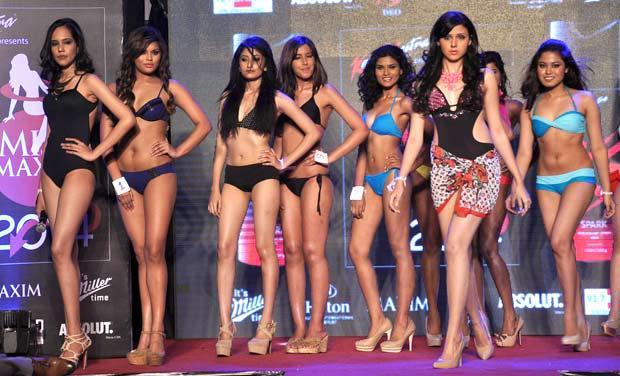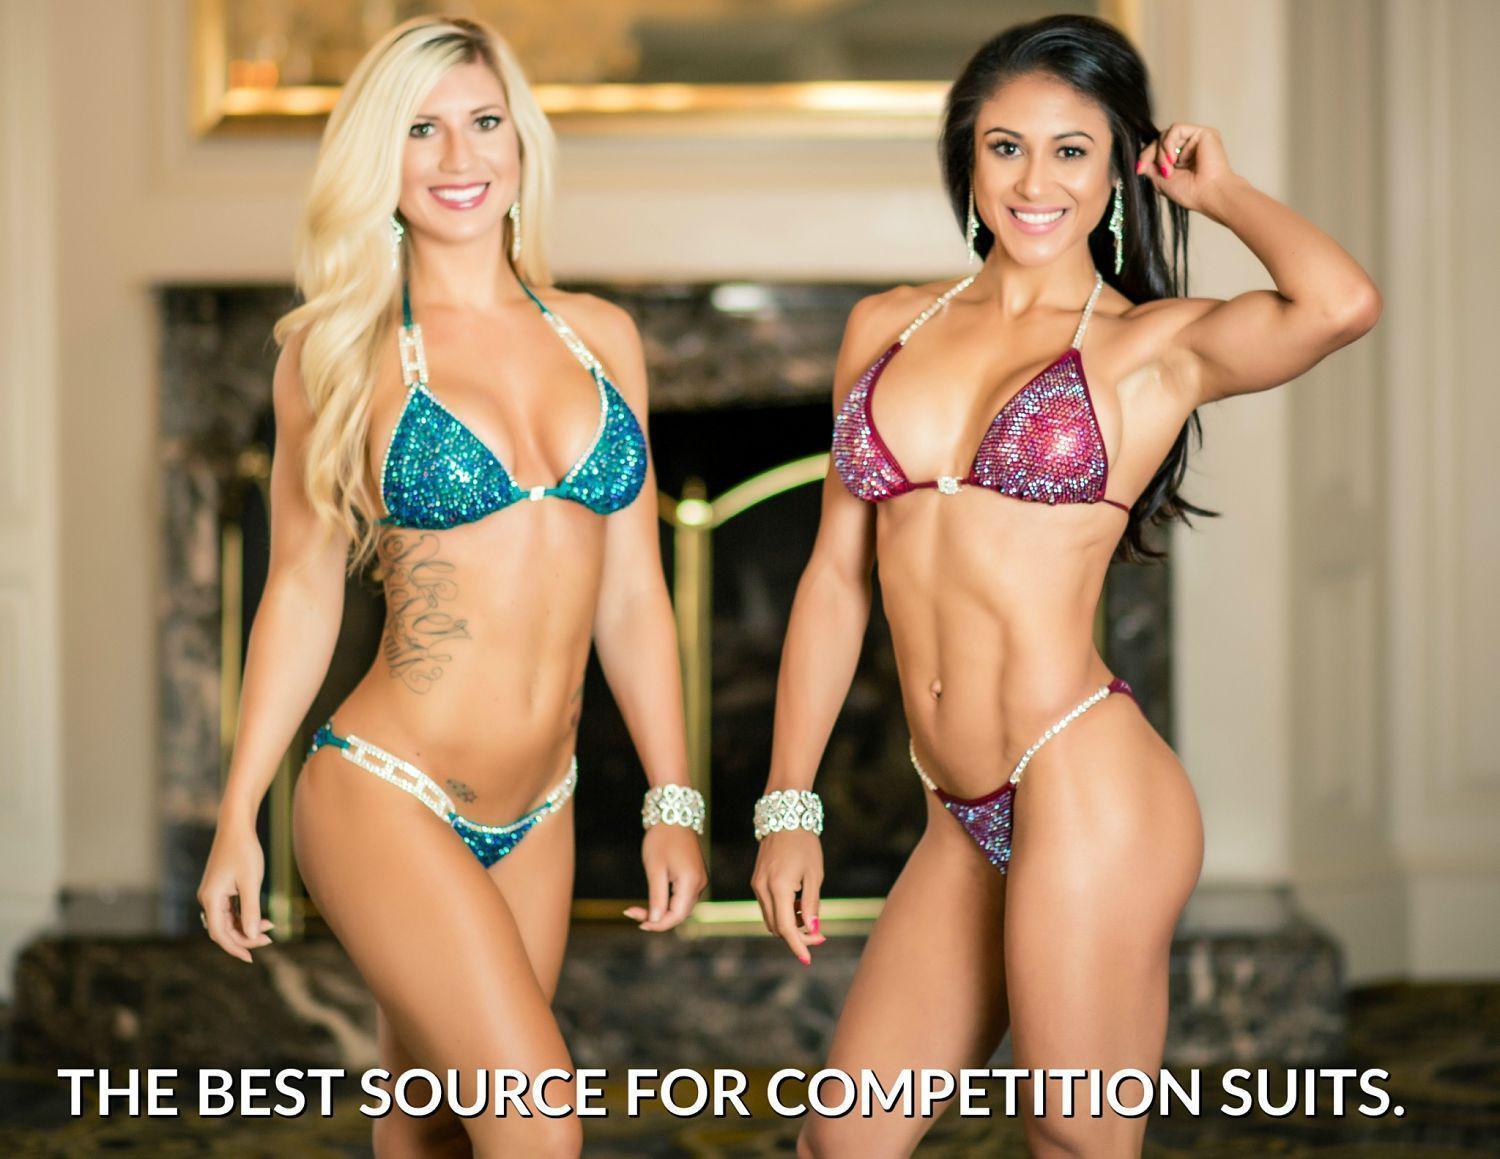The first image is the image on the left, the second image is the image on the right. Considering the images on both sides, is "In at least one image there are at least two identical women in blue bikinis." valid? Answer yes or no. No. 